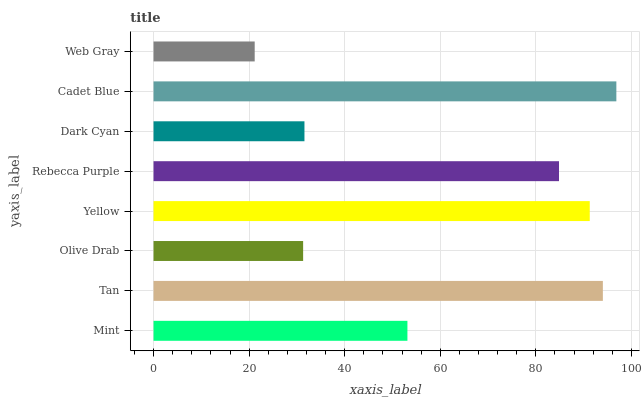Is Web Gray the minimum?
Answer yes or no. Yes. Is Cadet Blue the maximum?
Answer yes or no. Yes. Is Tan the minimum?
Answer yes or no. No. Is Tan the maximum?
Answer yes or no. No. Is Tan greater than Mint?
Answer yes or no. Yes. Is Mint less than Tan?
Answer yes or no. Yes. Is Mint greater than Tan?
Answer yes or no. No. Is Tan less than Mint?
Answer yes or no. No. Is Rebecca Purple the high median?
Answer yes or no. Yes. Is Mint the low median?
Answer yes or no. Yes. Is Yellow the high median?
Answer yes or no. No. Is Dark Cyan the low median?
Answer yes or no. No. 